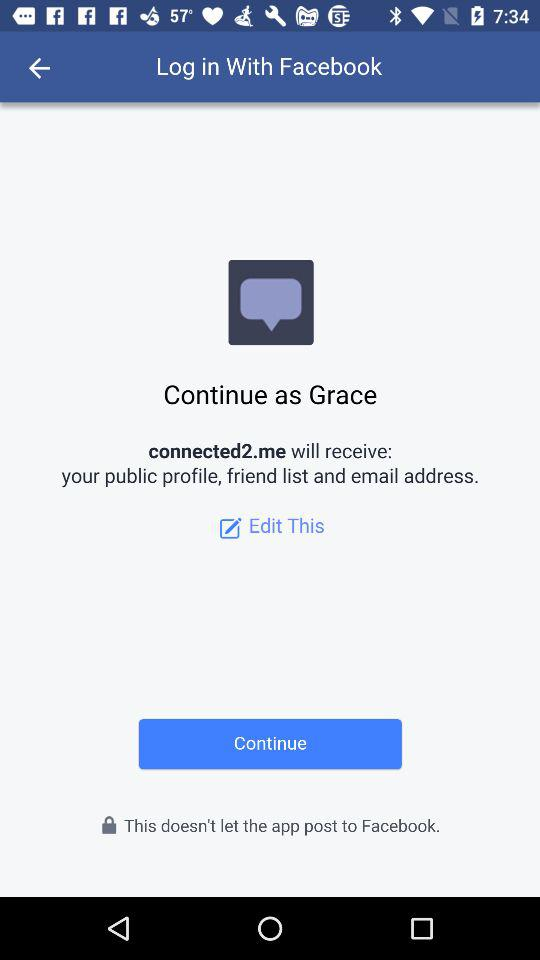What is the username? The username is Grace. 